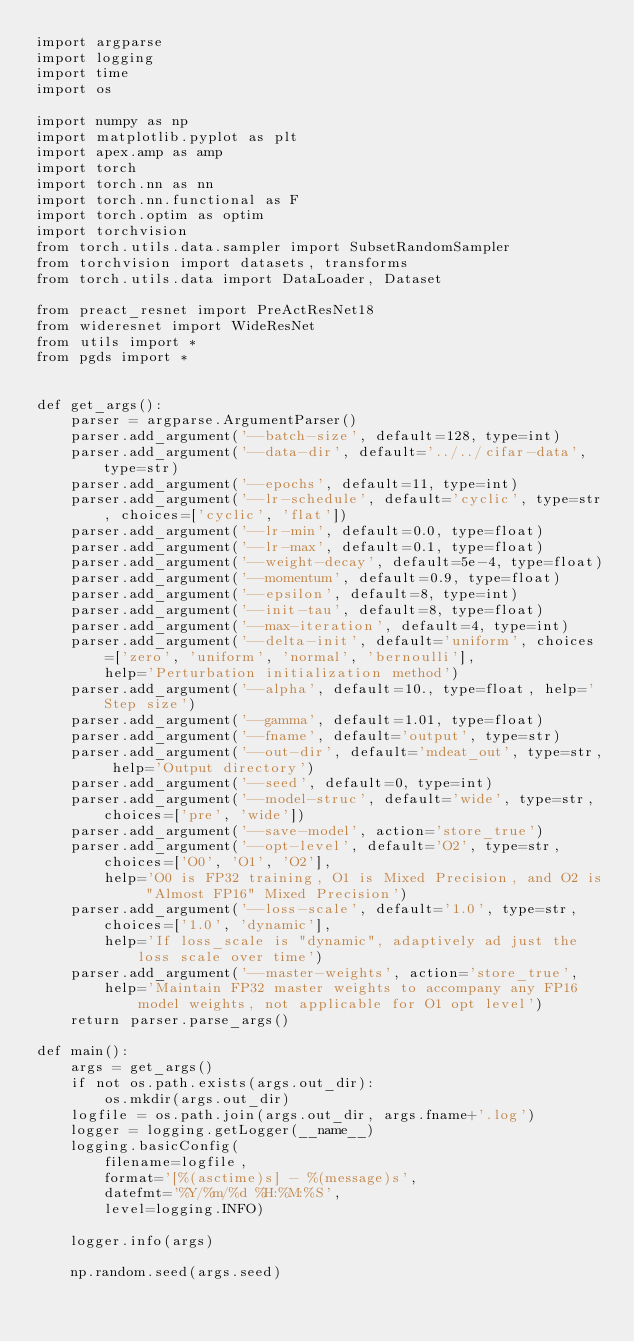<code> <loc_0><loc_0><loc_500><loc_500><_Python_>import argparse
import logging
import time
import os

import numpy as np
import matplotlib.pyplot as plt
import apex.amp as amp
import torch
import torch.nn as nn
import torch.nn.functional as F
import torch.optim as optim
import torchvision
from torch.utils.data.sampler import SubsetRandomSampler
from torchvision import datasets, transforms
from torch.utils.data import DataLoader, Dataset

from preact_resnet import PreActResNet18
from wideresnet import WideResNet
from utils import *
from pgds import *


def get_args():
    parser = argparse.ArgumentParser()
    parser.add_argument('--batch-size', default=128, type=int)
    parser.add_argument('--data-dir', default='../../cifar-data', type=str)
    parser.add_argument('--epochs', default=11, type=int)
    parser.add_argument('--lr-schedule', default='cyclic', type=str, choices=['cyclic', 'flat'])
    parser.add_argument('--lr-min', default=0.0, type=float)
    parser.add_argument('--lr-max', default=0.1, type=float)
    parser.add_argument('--weight-decay', default=5e-4, type=float)
    parser.add_argument('--momentum', default=0.9, type=float)
    parser.add_argument('--epsilon', default=8, type=int)
    parser.add_argument('--init-tau', default=8, type=float)
    parser.add_argument('--max-iteration', default=4, type=int)
    parser.add_argument('--delta-init', default='uniform', choices=['zero', 'uniform', 'normal', 'bernoulli'],
        help='Perturbation initialization method')
    parser.add_argument('--alpha', default=10., type=float, help='Step size')
    parser.add_argument('--gamma', default=1.01, type=float)
    parser.add_argument('--fname', default='output', type=str)
    parser.add_argument('--out-dir', default='mdeat_out', type=str, help='Output directory')
    parser.add_argument('--seed', default=0, type=int)
    parser.add_argument('--model-struc', default='wide', type=str, choices=['pre', 'wide'])
    parser.add_argument('--save-model', action='store_true')
    parser.add_argument('--opt-level', default='O2', type=str, choices=['O0', 'O1', 'O2'],
        help='O0 is FP32 training, O1 is Mixed Precision, and O2 is "Almost FP16" Mixed Precision')
    parser.add_argument('--loss-scale', default='1.0', type=str, choices=['1.0', 'dynamic'],
        help='If loss_scale is "dynamic", adaptively ad just the loss scale over time')
    parser.add_argument('--master-weights', action='store_true',
        help='Maintain FP32 master weights to accompany any FP16 model weights, not applicable for O1 opt level')
    return parser.parse_args()

def main():
    args = get_args()
    if not os.path.exists(args.out_dir):
        os.mkdir(args.out_dir)
    logfile = os.path.join(args.out_dir, args.fname+'.log')
    logger = logging.getLogger(__name__)
    logging.basicConfig(
        filename=logfile,
        format='[%(asctime)s] - %(message)s',
        datefmt='%Y/%m/%d %H:%M:%S',
        level=logging.INFO)

    logger.info(args)

    np.random.seed(args.seed)</code> 